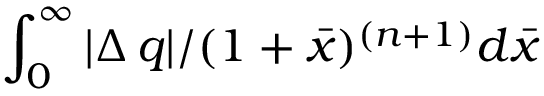Convert formula to latex. <formula><loc_0><loc_0><loc_500><loc_500>\int _ { 0 } ^ { \infty } | \Delta \, q | / ( 1 + \bar { x } ) ^ { ( n + 1 ) } d \bar { x }</formula> 